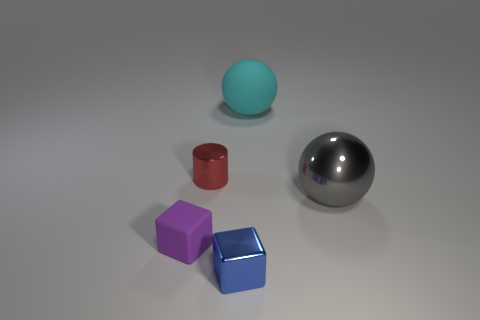Add 1 large red cylinders. How many objects exist? 6 Add 2 tiny purple matte cubes. How many tiny purple matte cubes exist? 3 Subtract 0 blue spheres. How many objects are left? 5 Subtract all cubes. How many objects are left? 3 Subtract all big shiny blocks. Subtract all big cyan matte objects. How many objects are left? 4 Add 5 red shiny things. How many red shiny things are left? 6 